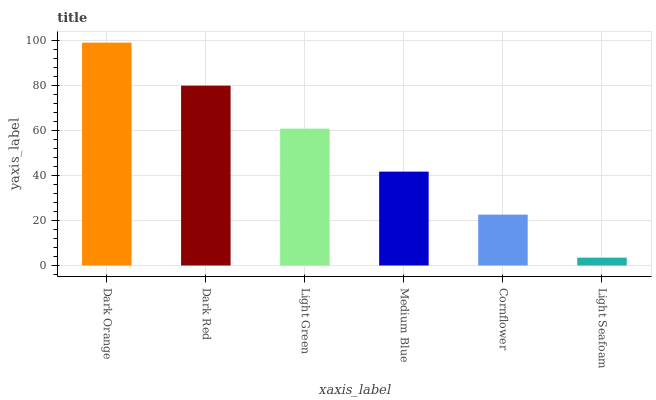Is Light Seafoam the minimum?
Answer yes or no. Yes. Is Dark Orange the maximum?
Answer yes or no. Yes. Is Dark Red the minimum?
Answer yes or no. No. Is Dark Red the maximum?
Answer yes or no. No. Is Dark Orange greater than Dark Red?
Answer yes or no. Yes. Is Dark Red less than Dark Orange?
Answer yes or no. Yes. Is Dark Red greater than Dark Orange?
Answer yes or no. No. Is Dark Orange less than Dark Red?
Answer yes or no. No. Is Light Green the high median?
Answer yes or no. Yes. Is Medium Blue the low median?
Answer yes or no. Yes. Is Medium Blue the high median?
Answer yes or no. No. Is Cornflower the low median?
Answer yes or no. No. 